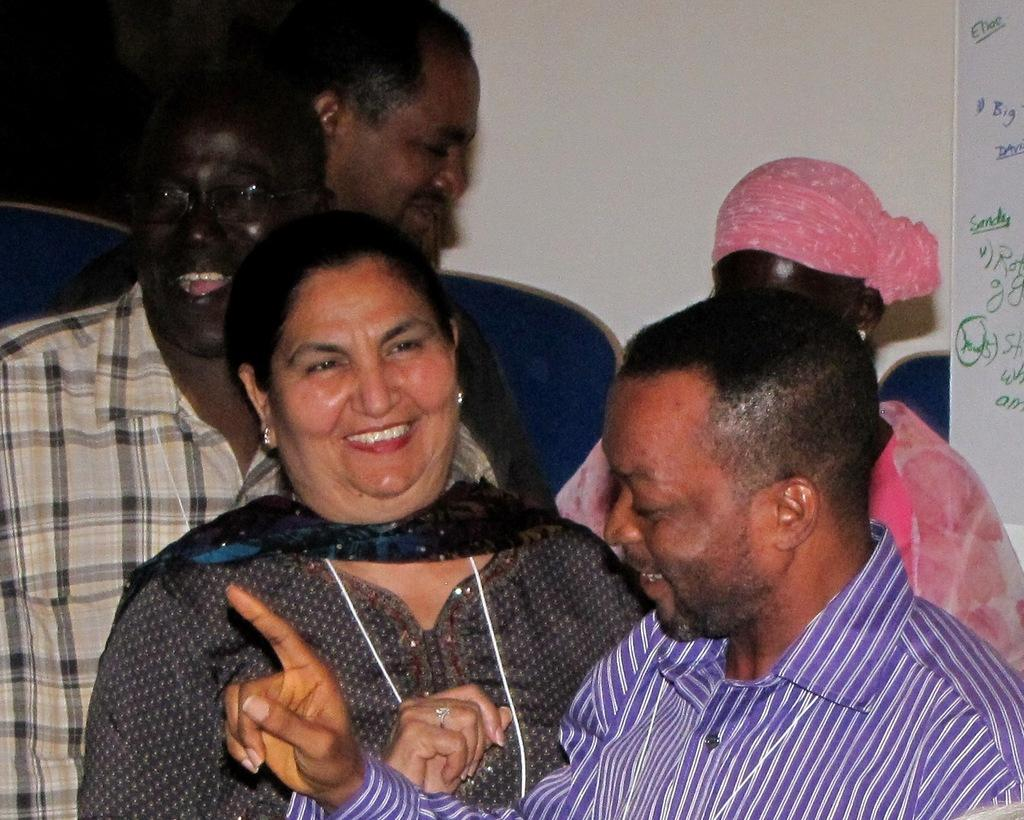What is the main subject of the image? The main subject of the image is a group of people. Where are the people located in the image? The group of people is standing in the center of the image. What can be seen on the right hand side of the image? There is a board on the right hand side of the image. What is written or depicted on the board? The board has some text on it. How many chins can be seen on the people in the image? It is impossible to determine the number of chins on the people in the image, as the image does not provide a close-up view of their faces. 